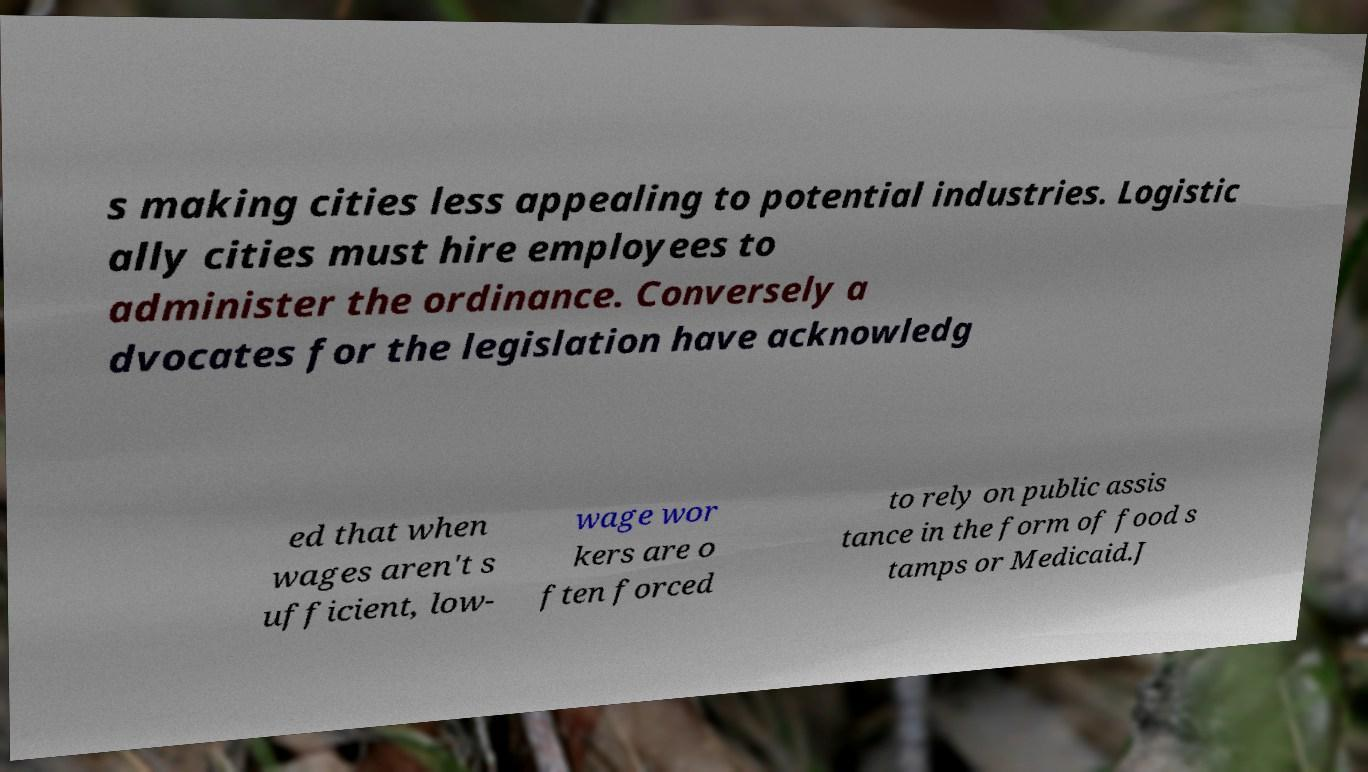Please identify and transcribe the text found in this image. s making cities less appealing to potential industries. Logistic ally cities must hire employees to administer the ordinance. Conversely a dvocates for the legislation have acknowledg ed that when wages aren't s ufficient, low- wage wor kers are o ften forced to rely on public assis tance in the form of food s tamps or Medicaid.J 